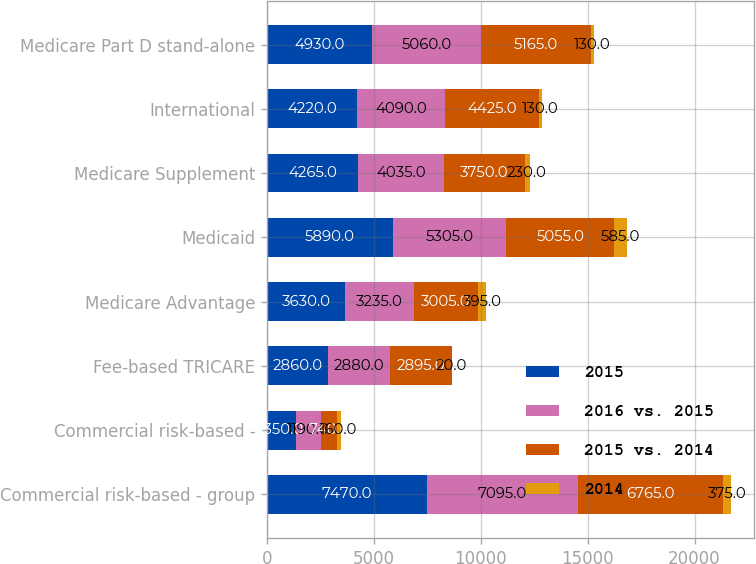Convert chart. <chart><loc_0><loc_0><loc_500><loc_500><stacked_bar_chart><ecel><fcel>Commercial risk-based - group<fcel>Commercial risk-based -<fcel>Fee-based TRICARE<fcel>Medicare Advantage<fcel>Medicaid<fcel>Medicare Supplement<fcel>International<fcel>Medicare Part D stand-alone<nl><fcel>2015<fcel>7470<fcel>1350<fcel>2860<fcel>3630<fcel>5890<fcel>4265<fcel>4220<fcel>4930<nl><fcel>2016 vs. 2015<fcel>7095<fcel>1190<fcel>2880<fcel>3235<fcel>5305<fcel>4035<fcel>4090<fcel>5060<nl><fcel>2015 vs. 2014<fcel>6765<fcel>740<fcel>2895<fcel>3005<fcel>5055<fcel>3750<fcel>4425<fcel>5165<nl><fcel>2014<fcel>375<fcel>160<fcel>20<fcel>395<fcel>585<fcel>230<fcel>130<fcel>130<nl></chart> 